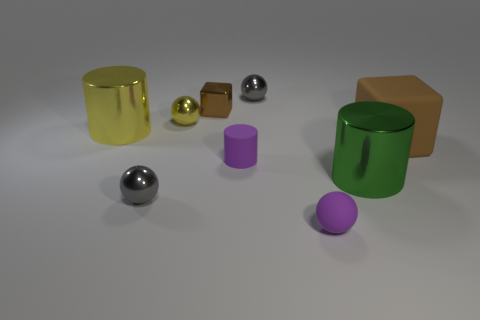Subtract all cylinders. How many objects are left? 6 Subtract all gray shiny balls. Subtract all metallic things. How many objects are left? 1 Add 1 gray metal objects. How many gray metal objects are left? 3 Add 2 tiny spheres. How many tiny spheres exist? 6 Subtract 0 gray cylinders. How many objects are left? 9 